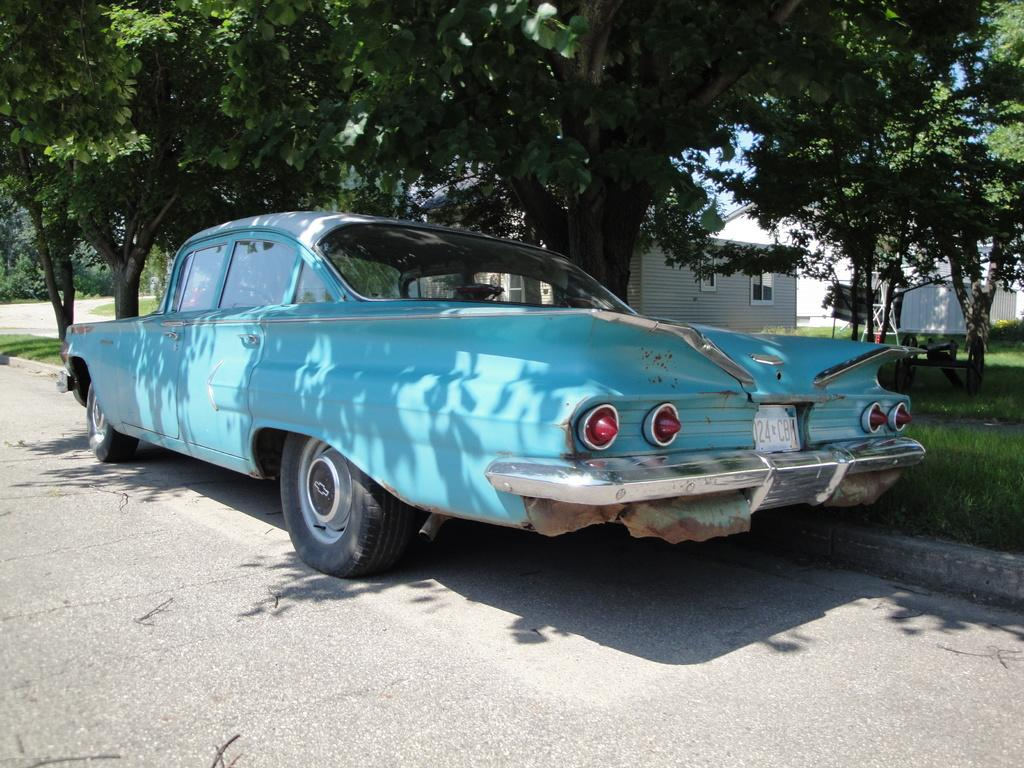What is the main subject of the image? The main subject of the subject of the image is a car. Where is the car located in the image? The car is on the road in the image. What can be seen in the background of the image? There are houses, trees, and grass in the background of the image. What type of magic is being performed by the plants in the image? There are no plants performing magic in the image; the background features houses, trees, and grass. 